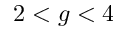<formula> <loc_0><loc_0><loc_500><loc_500>2 < g < 4</formula> 